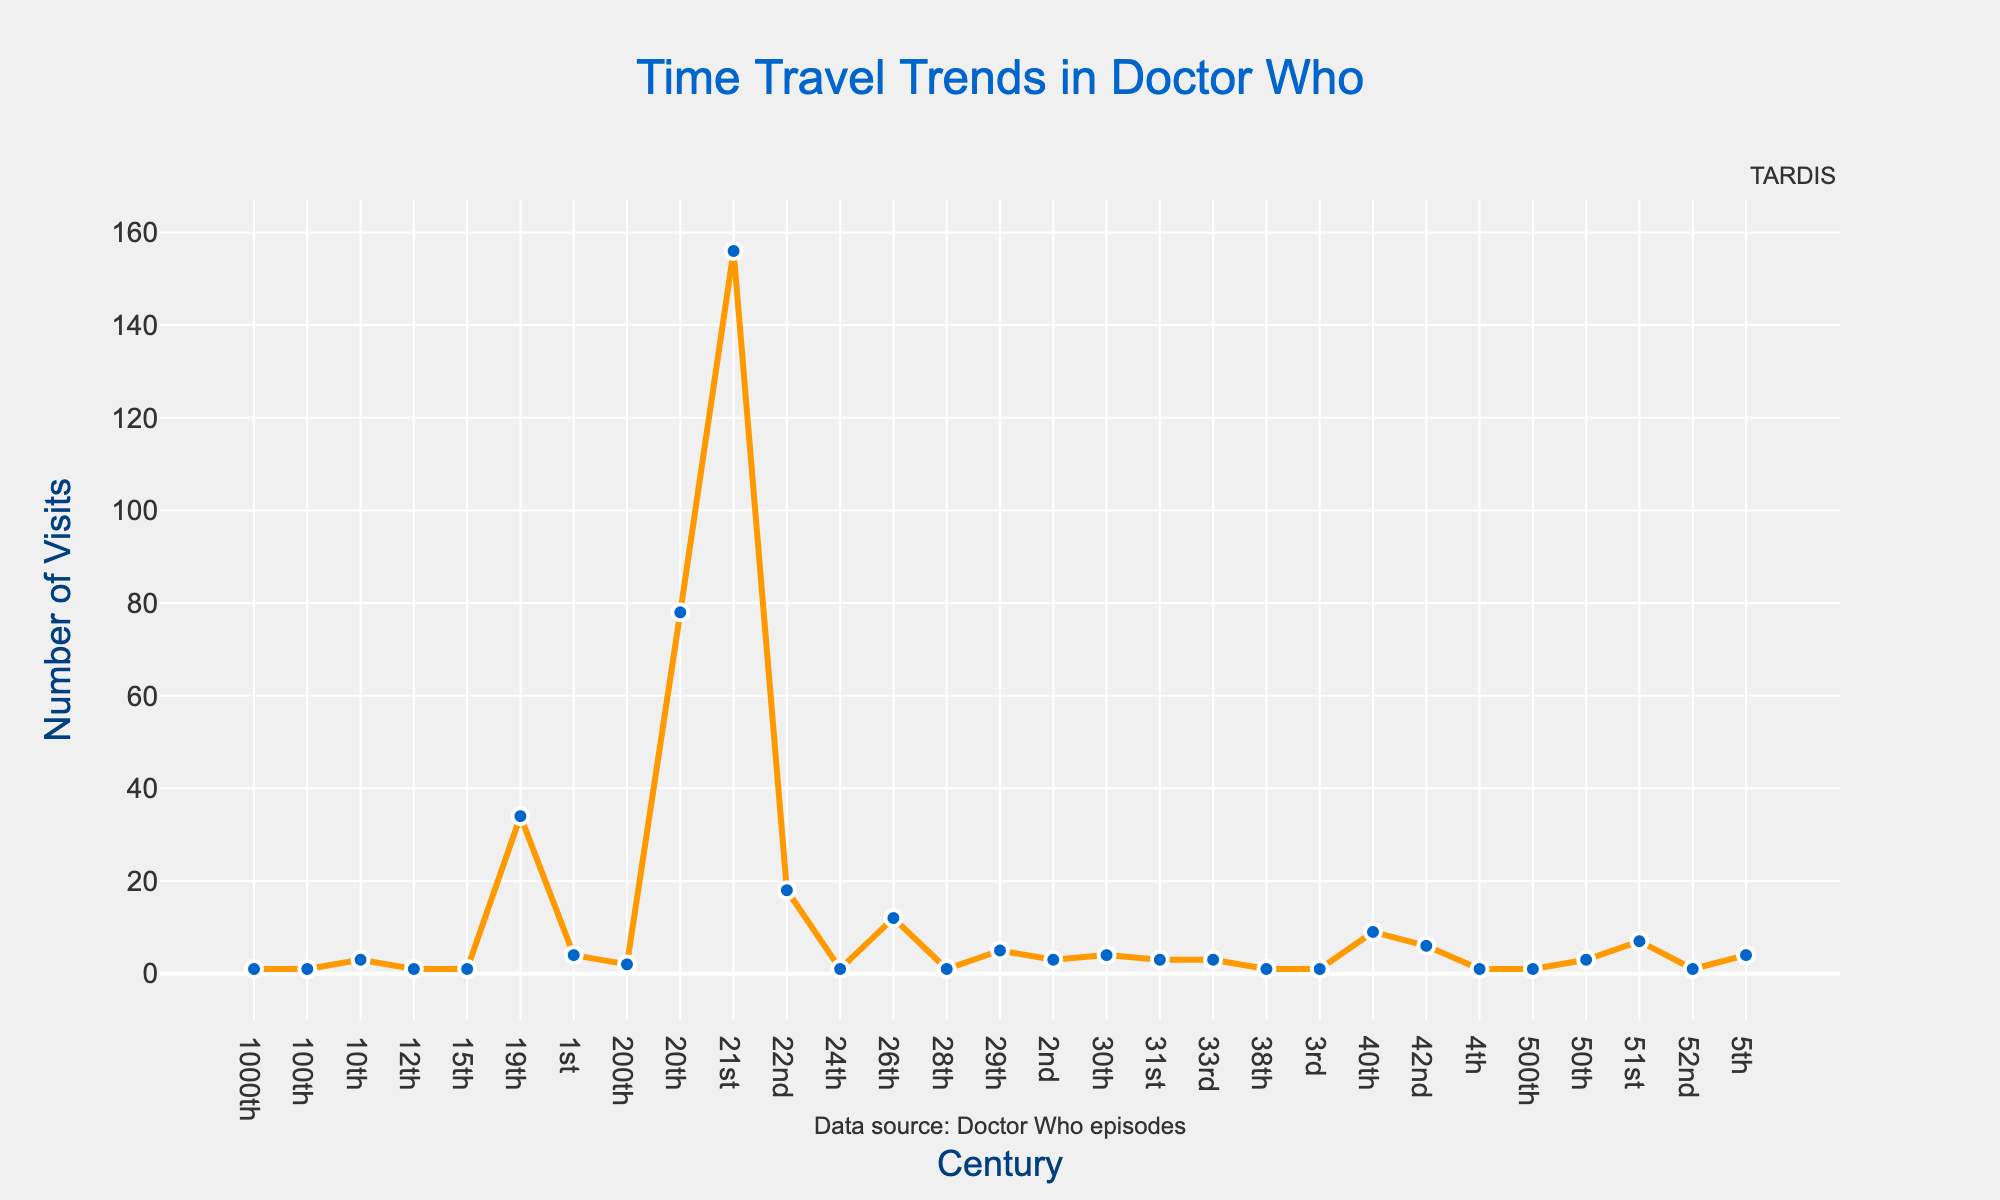How many centuries are depicted in the figure? To determine the number of centuries depicted, count all unique entries along the x-axis in the chart.
Answer: 29 Which century has the highest number of visits? Look for the data point with the highest y-value on the line chart. The marker at this point corresponds to the 21st century with a frequency of 156.
Answer: 21st By how much does the number of visits to the 21st century exceed those to the 20th century? Identify the y-values for the 21st and 20th centuries: 156 and 78, respectively. Subtract the 20th century value from the 21st century value (156 - 78 = 78).
Answer: 78 What is the median frequency of visits across all centuries depicted? First, list out the frequencies and arrange them in ascending order. The middle value in this sorted list represents the median. If there's an even number of values, the median is the average of the two central numbers. Frequencies: [1, 1, 1, 1, 1, 1, 2, 3, 3, 3, 3, 4, 4, 4, 5, 6, 7, 9, 12, 18, 34, 78, 156]. With 29 values, the median is the 15th value in the ordered list, i.e., 4.
Answer: 4 Compare the number of visits to the 51st century and the 50th century. Which has more visits? Locate the markers on the line chart for the 50th and 51st centuries. The 50th century has a frequency of 3, whereas the 51st century has 7. So, the 51st century has more visits.
Answer: 51st How many centuries have a frequency of visits greater than or equal to 10? Identify the points on the line chart with y-values 10 or more. These correspond to the centuries with such frequencies. Centuries: 21st (156), 20th (78), 19th (34), 22nd (18), 26th (12), 40th (9) - the last being just under 10, so exclude it. Four centuries meet the criteria.
Answer: 4 What is the combined frequency of visits for the 10th and 30th centuries? Find their respective y-values: the 10th century is 3 and the 30th century is 4. Adding these together gives 3 + 4 = 7.
Answer: 7 Identify the century with the least amount of visits and state how many visits it has. Locate the data points with the smallest y-values. Given multiple centuries have a frequency of 1 (3rd, 4th, etc.), any of these can be considered since they tie for the least amount.
Answer: 1 